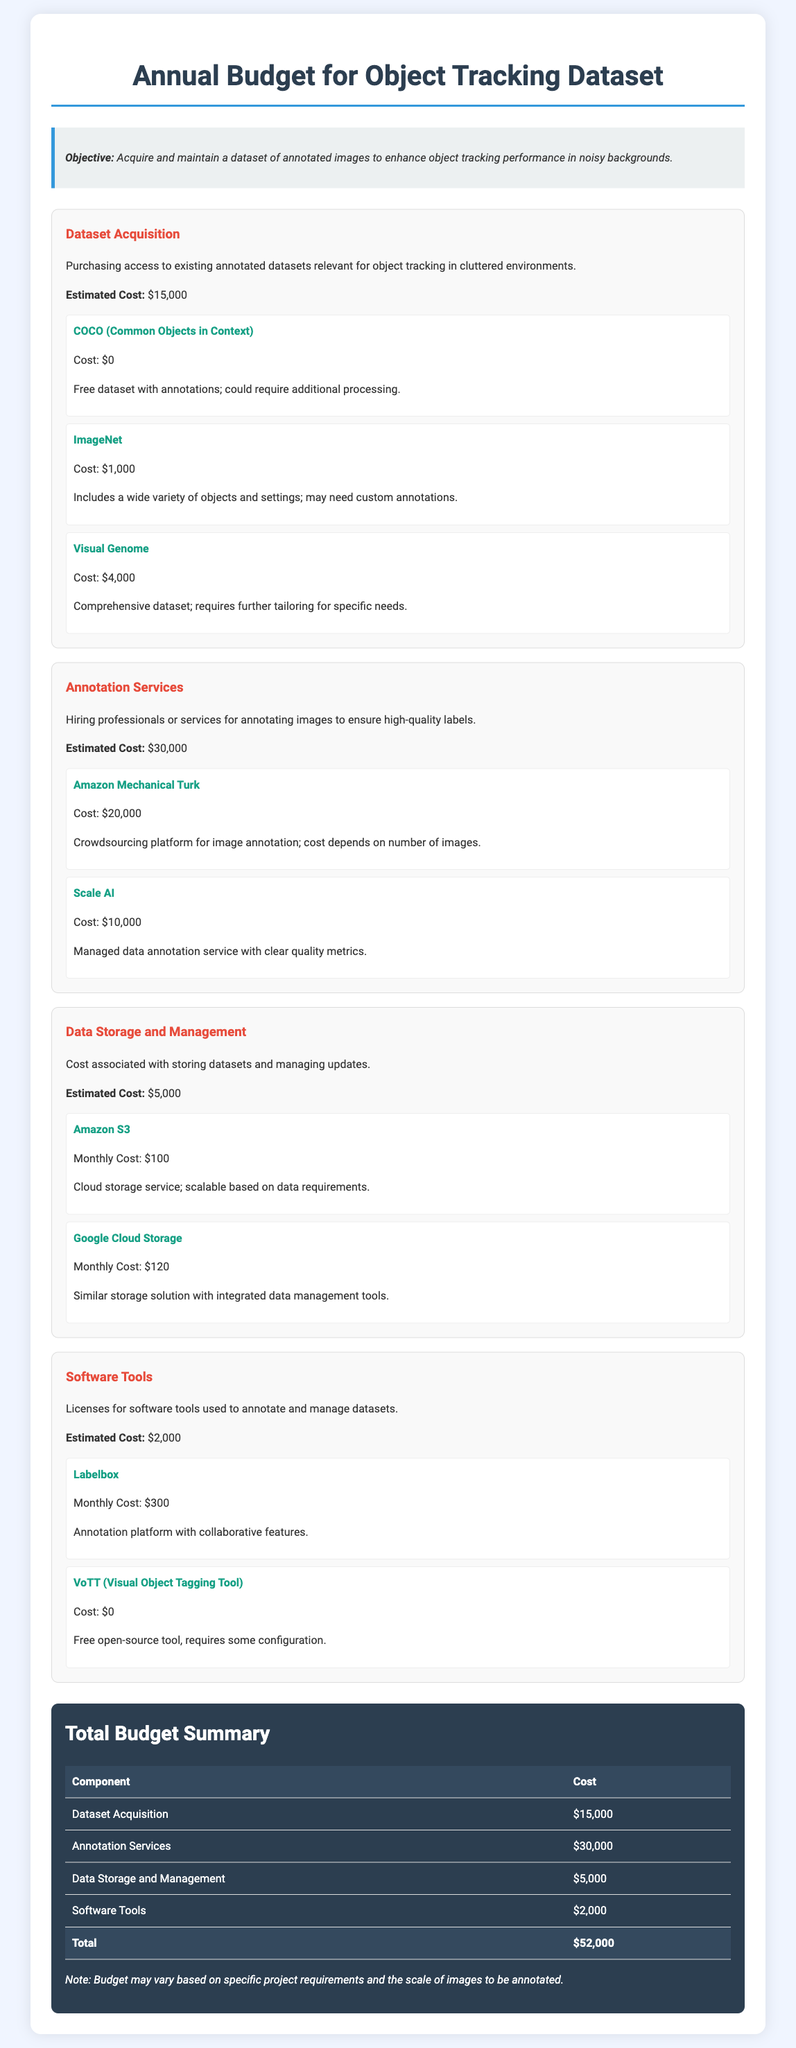what is the total budget? The total budget is the sum of all cost components listed in the document.
Answer: $52,000 what is the estimated cost for annotation services? The estimated cost for annotation services is specified in the document.
Answer: $30,000 what dataset is provided for free? The document mentions a dataset that has no cost associated with it.
Answer: COCO how much does ImageNet cost? The document specifies the cost associated with acquiring the ImageNet dataset.
Answer: $1,000 what is the purpose of the annual budget? The document explicitly states the objective of the budget at the beginning.
Answer: Enhance object tracking performance in noisy backgrounds which cloud storage service has a monthly cost of $120? The document lists the costs of different storage services, including one with this monthly fee.
Answer: Google Cloud Storage how much is the estimated cost for data storage and management? The estimated cost for data storage and management is outlined in the document.
Answer: $5,000 how much does Labelbox cost per month? The document provides a monthly cost for Labelbox.
Answer: $300 what is the estimated cost of dataset acquisition? The document lists the estimated cost specifically for dataset acquisition.
Answer: $15,000 